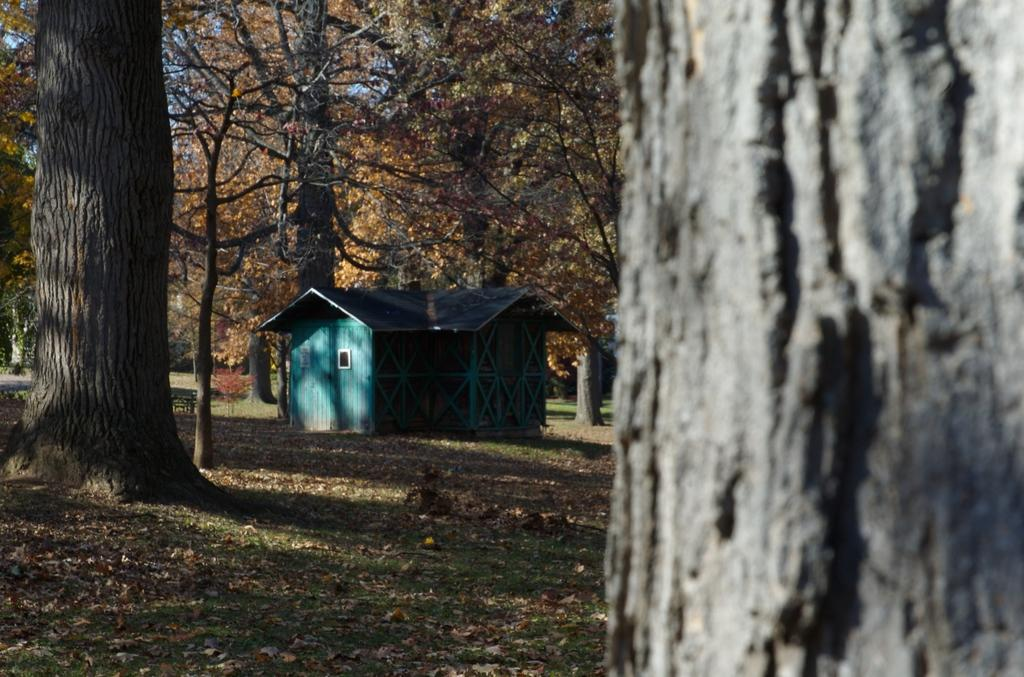What type of structure is visible in the image? There is a house in the image. What is covering the ground in the image? The ground is covered with grass and dried leaves. Are there any plants visible in the image? Yes, there are a few trees in the image. How does the drain help with the water flow in the image? There is no drain present in the image, so it cannot help with water flow. 